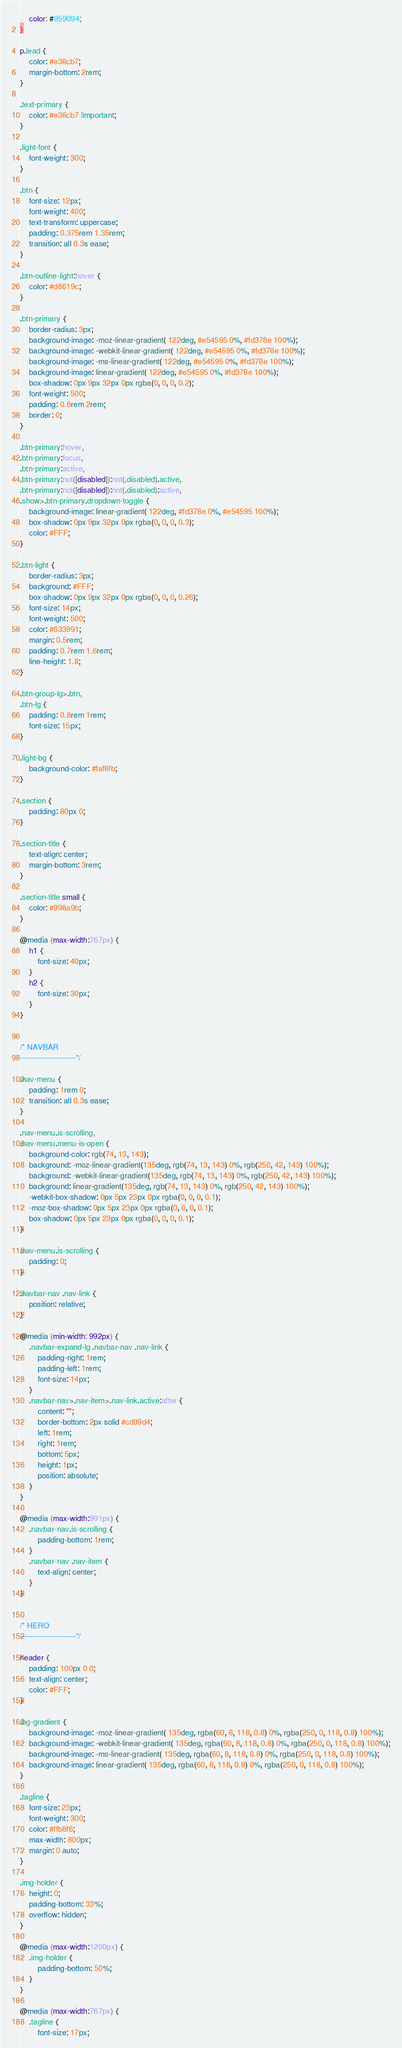<code> <loc_0><loc_0><loc_500><loc_500><_CSS_>    color: #959094;
}

p.lead {
    color: #e38cb7;
    margin-bottom: 2rem;
}

.text-primary {
    color: #e38cb7 !important;
}

.light-font {
    font-weight: 300;
}

.btn {
    font-size: 12px;
    font-weight: 400;
    text-transform: uppercase;
    padding: 0.375rem 1.35rem;
    transition: all 0.3s ease;
}

.btn-outline-light:hover {
    color: #d6619c;
}

.btn-primary {
    border-radius: 3px;
    background-image: -moz-linear-gradient( 122deg, #e54595 0%, #fd378e 100%);
    background-image: -webkit-linear-gradient( 122deg, #e54595 0%, #fd378e 100%);
    background-image: -ms-linear-gradient( 122deg, #e54595 0%, #fd378e 100%);
    background-image: linear-gradient( 122deg, #e54595 0%, #fd378e 100%);
    box-shadow: 0px 9px 32px 0px rgba(0, 0, 0, 0.2);
    font-weight: 500;
    padding: 0.6rem 2rem;
    border: 0;
}

.btn-primary:hover,
.btn-primary:focus,
.btn-primary:active,
.btn-primary:not([disabled]):not(.disabled).active,
.btn-primary:not([disabled]):not(.disabled):active,
.show>.btn-primary.dropdown-toggle {
    background-image: linear-gradient( 122deg, #fd378e 0%, #e54595 100%);
    box-shadow: 0px 9px 32px 0px rgba(0, 0, 0, 0.3);
    color: #FFF;
}

.btn-light {
    border-radius: 3px;
    background: #FFF;
    box-shadow: 0px 9px 32px 0px rgba(0, 0, 0, 0.26);
    font-size: 14px;
    font-weight: 500;
    color: #633991;
    margin: 0.5rem;
    padding: 0.7rem 1.6rem;
    line-height: 1.8;
}

.btn-group-lg>.btn,
.btn-lg {
    padding: 0.8rem 1rem;
    font-size: 15px;
}

.light-bg {
    background-color: #faf6fb;
}

.section {
    padding: 80px 0;
}

.section-title {
    text-align: center;
    margin-bottom: 3rem;
}

.section-title small {
    color: #998a9b;
}

@media (max-width:767px) {
    h1 {
        font-size: 40px;
    }
    h2 {
        font-size: 30px;
    }
}


/* NAVBAR
----------------------*/

.nav-menu {
    padding: 1rem 0;
    transition: all 0.3s ease;
}

.nav-menu.is-scrolling,
.nav-menu.menu-is-open {
    background-color: rgb(74, 13, 143);
    background: -moz-linear-gradient(135deg, rgb(74, 13, 143) 0%, rgb(250, 42, 143) 100%);
    background: -webkit-linear-gradient(135deg, rgb(74, 13, 143) 0%, rgb(250, 42, 143) 100%);
    background: linear-gradient(135deg, rgb(74, 13, 143) 0%, rgb(250, 42, 143) 100%);
    -webkit-box-shadow: 0px 5px 23px 0px rgba(0, 0, 0, 0.1);
    -moz-box-shadow: 0px 5px 23px 0px rgba(0, 0, 0, 0.1);
    box-shadow: 0px 5px 23px 0px rgba(0, 0, 0, 0.1);
}

.nav-menu.is-scrolling {
    padding: 0;
}

.navbar-nav .nav-link {
    position: relative;
}

@media (min-width: 992px) {
    .navbar-expand-lg .navbar-nav .nav-link {
        padding-right: 1rem;
        padding-left: 1rem;
        font-size: 14px;
    }
    .navbar-nav>.nav-item>.nav-link.active:after {
        content: "";
        border-bottom: 2px solid #cd99d4;
        left: 1rem;
        right: 1rem;
        bottom: 5px;
        height: 1px;
        position: absolute;
    }
}

@media (max-width:991px) {
    .navbar-nav.is-scrolling {
        padding-bottom: 1rem;
    }
    .navbar-nav .nav-item {
        text-align: center;
    }
}


/* HERO
----------------------*/

header {
    padding: 100px 0 0;
    text-align: center;
    color: #FFF;
}

.bg-gradient {
    background-image: -moz-linear-gradient( 135deg, rgba(60, 8, 118, 0.8) 0%, rgba(250, 0, 118, 0.8) 100%);
    background-image: -webkit-linear-gradient( 135deg, rgba(60, 8, 118, 0.8) 0%, rgba(250, 0, 118, 0.8) 100%);
    background-image: -ms-linear-gradient( 135deg, rgba(60, 8, 118, 0.8) 0%, rgba(250, 0, 118, 0.8) 100%);
    background-image: linear-gradient( 135deg, rgba(60, 8, 118, 0.8) 0%, rgba(250, 0, 118, 0.8) 100%);
}

.tagline {
    font-size: 23px;
    font-weight: 300;
    color: #ffb8f6;
    max-width: 800px;
    margin: 0 auto;
}

.img-holder {
    height: 0;
    padding-bottom: 33%;
    overflow: hidden;
}

@media (max-width:1200px) {
    .img-holder {
        padding-bottom: 50%;
    }
}

@media (max-width:767px) {
    .tagline {
        font-size: 17px;</code> 